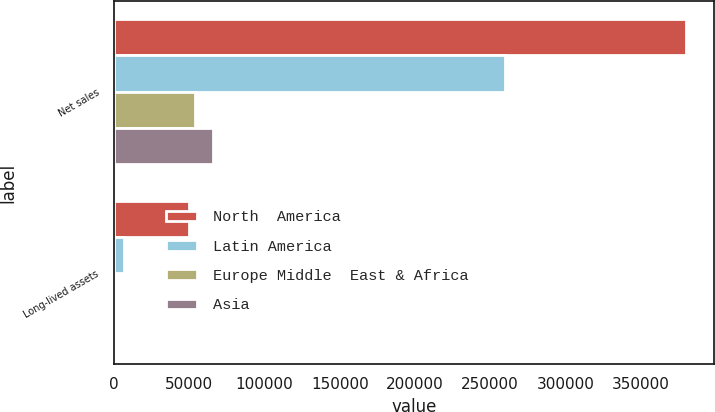Convert chart. <chart><loc_0><loc_0><loc_500><loc_500><stacked_bar_chart><ecel><fcel>Net sales<fcel>Long-lived assets<nl><fcel>North  America<fcel>379820<fcel>50077<nl><fcel>Latin America<fcel>260125<fcel>6637<nl><fcel>Europe Middle  East & Africa<fcel>53619<fcel>22<nl><fcel>Asia<fcel>65960<fcel>695<nl></chart> 